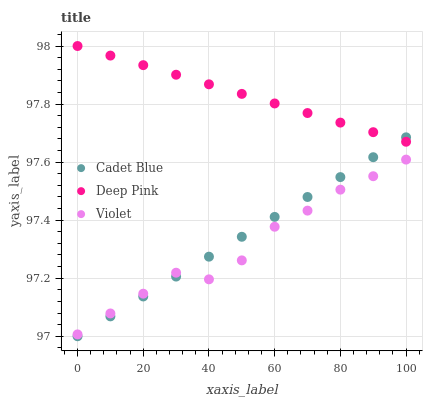Does Violet have the minimum area under the curve?
Answer yes or no. Yes. Does Deep Pink have the maximum area under the curve?
Answer yes or no. Yes. Does Deep Pink have the minimum area under the curve?
Answer yes or no. No. Does Violet have the maximum area under the curve?
Answer yes or no. No. Is Cadet Blue the smoothest?
Answer yes or no. Yes. Is Violet the roughest?
Answer yes or no. Yes. Is Deep Pink the smoothest?
Answer yes or no. No. Is Deep Pink the roughest?
Answer yes or no. No. Does Cadet Blue have the lowest value?
Answer yes or no. Yes. Does Violet have the lowest value?
Answer yes or no. No. Does Deep Pink have the highest value?
Answer yes or no. Yes. Does Violet have the highest value?
Answer yes or no. No. Is Violet less than Deep Pink?
Answer yes or no. Yes. Is Deep Pink greater than Violet?
Answer yes or no. Yes. Does Violet intersect Cadet Blue?
Answer yes or no. Yes. Is Violet less than Cadet Blue?
Answer yes or no. No. Is Violet greater than Cadet Blue?
Answer yes or no. No. Does Violet intersect Deep Pink?
Answer yes or no. No. 